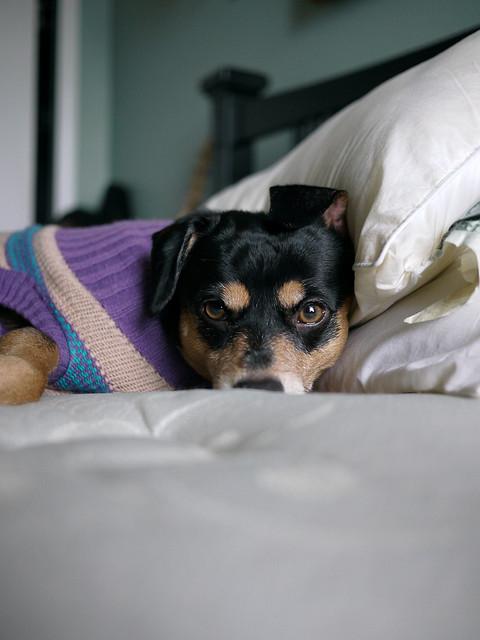Would it dress itself like that?
Concise answer only. No. What color are the dog's eyes?
Give a very brief answer. Brown. What animal is under the covers?
Give a very brief answer. Dog. 